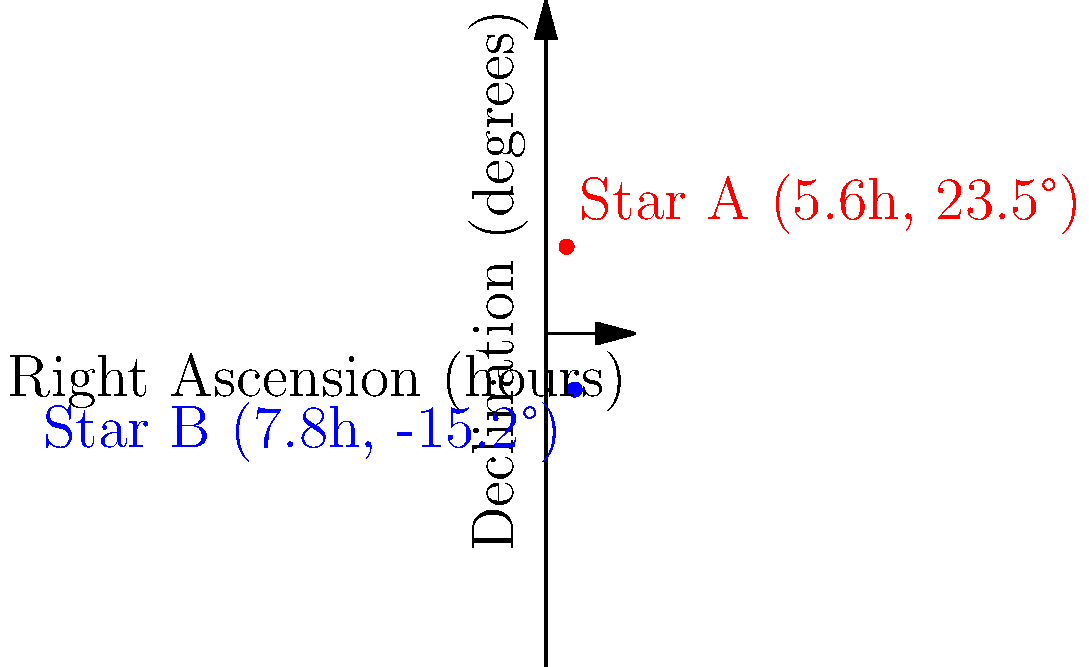Two stars, A and B, are observed in the night sky. Star A has celestial coordinates of right ascension (RA) 5.6 hours and declination (Dec) 23.5 degrees. Star B has coordinates of RA 7.8 hours and Dec -15.2 degrees. Calculate the angular separation between these two stars in degrees, given that the distance formula on a celestial sphere is:

$$\cos(\theta) = \sin(\delta_1)\sin(\delta_2) + \cos(\delta_1)\cos(\delta_2)\cos(\alpha_1 - \alpha_2)$$

where $\theta$ is the angular separation, $\delta_1$ and $\delta_2$ are the declinations, and $\alpha_1$ and $\alpha_2$ are the right ascensions (converted to degrees) of the two stars. To solve this problem, we'll follow these steps:

1) Convert RA from hours to degrees:
   RA of Star A: $5.6h \times 15°/h = 84°$
   RA of Star B: $7.8h \times 15°/h = 117°$

2) Assign variables:
   $\delta_1 = 23.5°$ (Dec of Star A)
   $\delta_2 = -15.2°$ (Dec of Star B)
   $\alpha_1 = 84°$ (RA of Star A)
   $\alpha_2 = 117°$ (RA of Star B)

3) Apply the formula:
   $$\cos(\theta) = \sin(23.5°)\sin(-15.2°) + \cos(23.5°)\cos(-15.2°)\cos(84° - 117°)$$

4) Calculate each term:
   $\sin(23.5°) = 0.3987$
   $\sin(-15.2°) = -0.2624$
   $\cos(23.5°) = 0.9171$
   $\cos(-15.2°) = 0.9649$
   $\cos(84° - 117°) = \cos(-33°) = 0.8387$

5) Substitute and calculate:
   $$\cos(\theta) = (0.3987)(-0.2624) + (0.9171)(0.9649)(0.8387)$$
   $$\cos(\theta) = -0.1046 + 0.7414 = 0.6368$$

6) Solve for $\theta$:
   $$\theta = \arccos(0.6368) = 50.4°$$

Therefore, the angular separation between the two stars is approximately 50.4 degrees.
Answer: 50.4° 